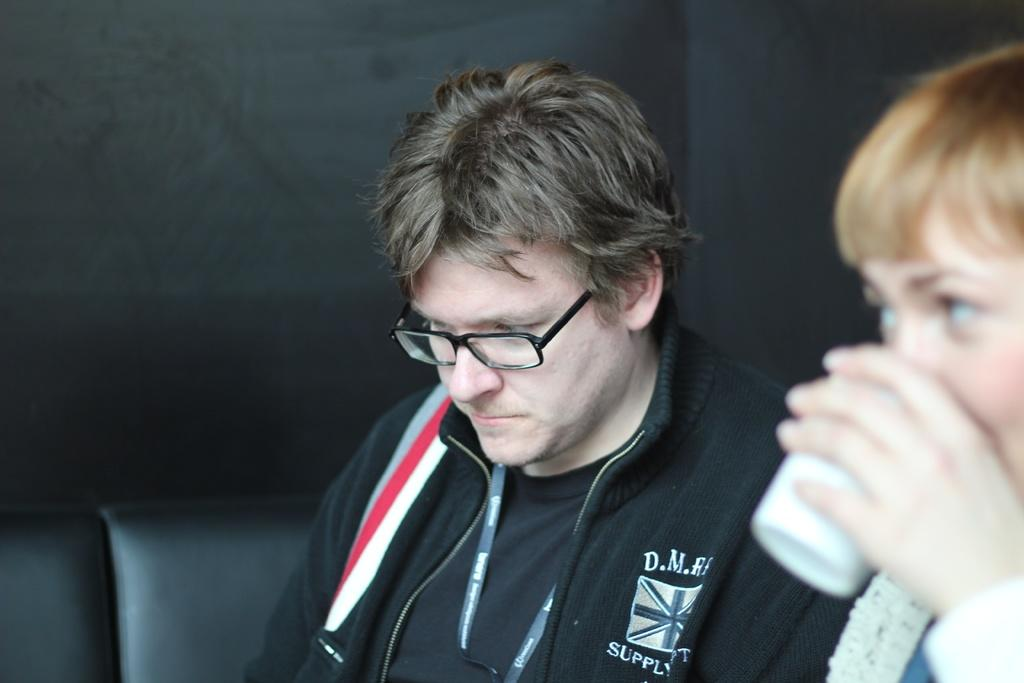What is the person on the left side of the image wearing? The person on the left is wearing a black dress. What accessory is the person on the left wearing? The person on the left is wearing spectacles. What is the person on the right side of the image holding? The person on the right is holding a glass. What is the color of the background in the image? The background of the image is black. What type of chalk is being used to draw on the metal surface in the image? There is no chalk or metal surface present in the image. 